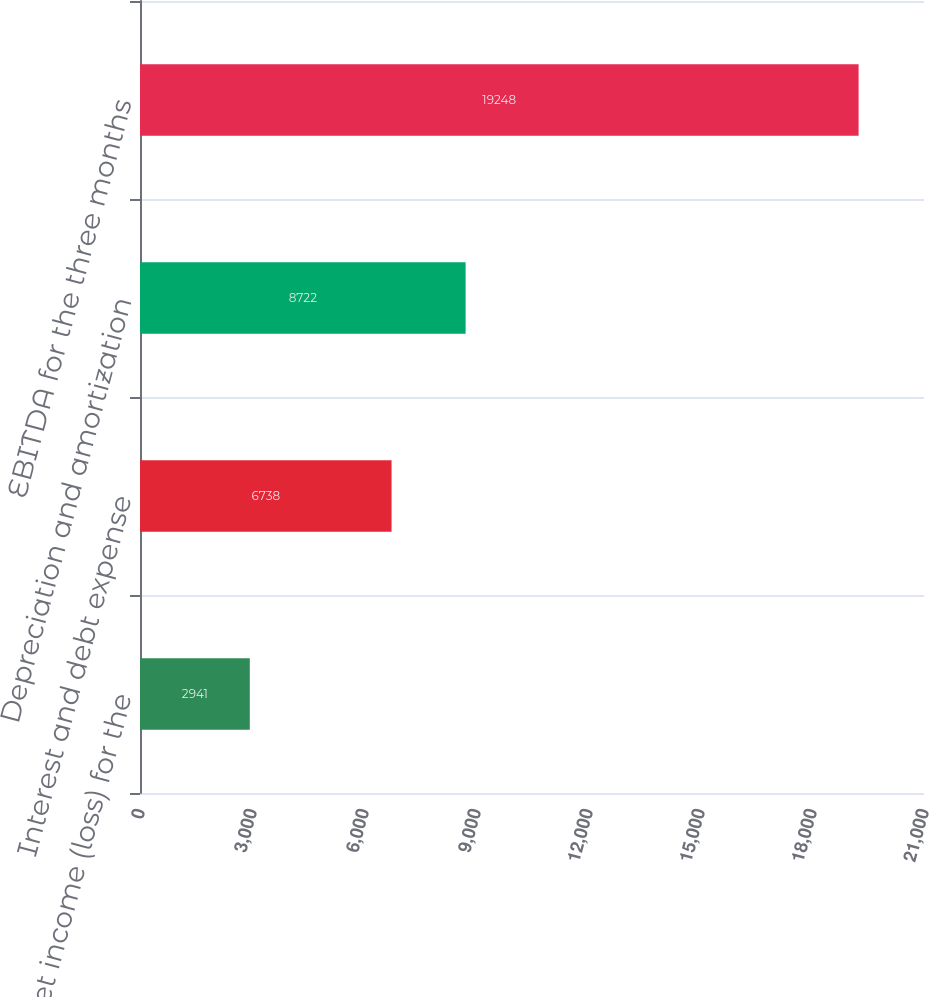Convert chart. <chart><loc_0><loc_0><loc_500><loc_500><bar_chart><fcel>Net income (loss) for the<fcel>Interest and debt expense<fcel>Depreciation and amortization<fcel>EBITDA for the three months<nl><fcel>2941<fcel>6738<fcel>8722<fcel>19248<nl></chart> 